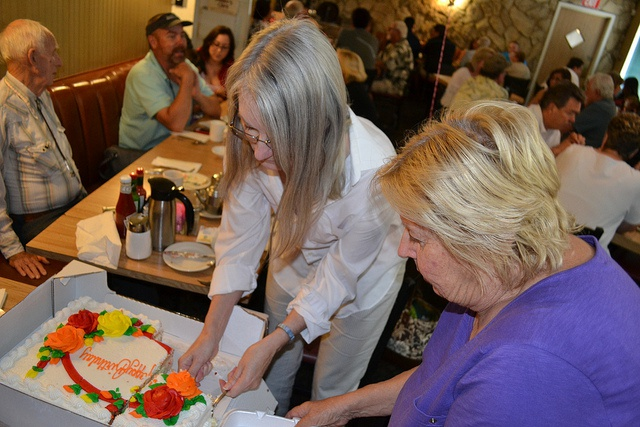Describe the objects in this image and their specific colors. I can see people in maroon, blue, gray, and tan tones, people in maroon, darkgray, and gray tones, dining table in maroon, brown, tan, and black tones, people in maroon, black, and brown tones, and cake in maroon, darkgray, tan, brown, and red tones in this image. 